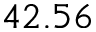Convert formula to latex. <formula><loc_0><loc_0><loc_500><loc_500>4 2 . 5 6</formula> 